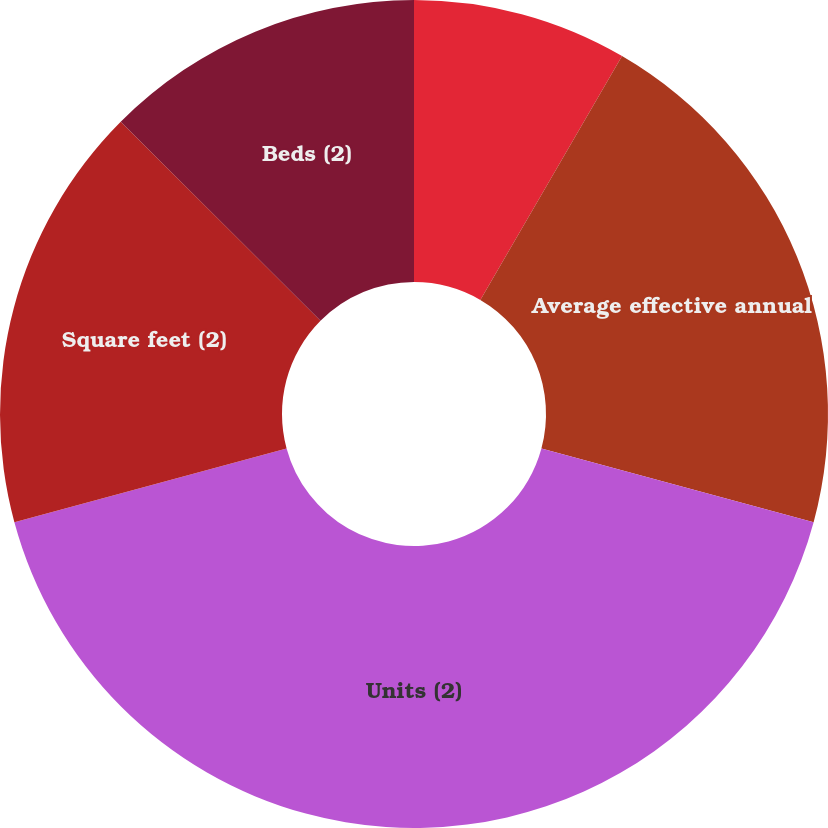<chart> <loc_0><loc_0><loc_500><loc_500><pie_chart><fcel>Average occupancy percentage<fcel>Average effective annual<fcel>Units (2)<fcel>Square feet (2)<fcel>Beds (2)<nl><fcel>8.38%<fcel>20.83%<fcel>41.59%<fcel>16.68%<fcel>12.53%<nl></chart> 